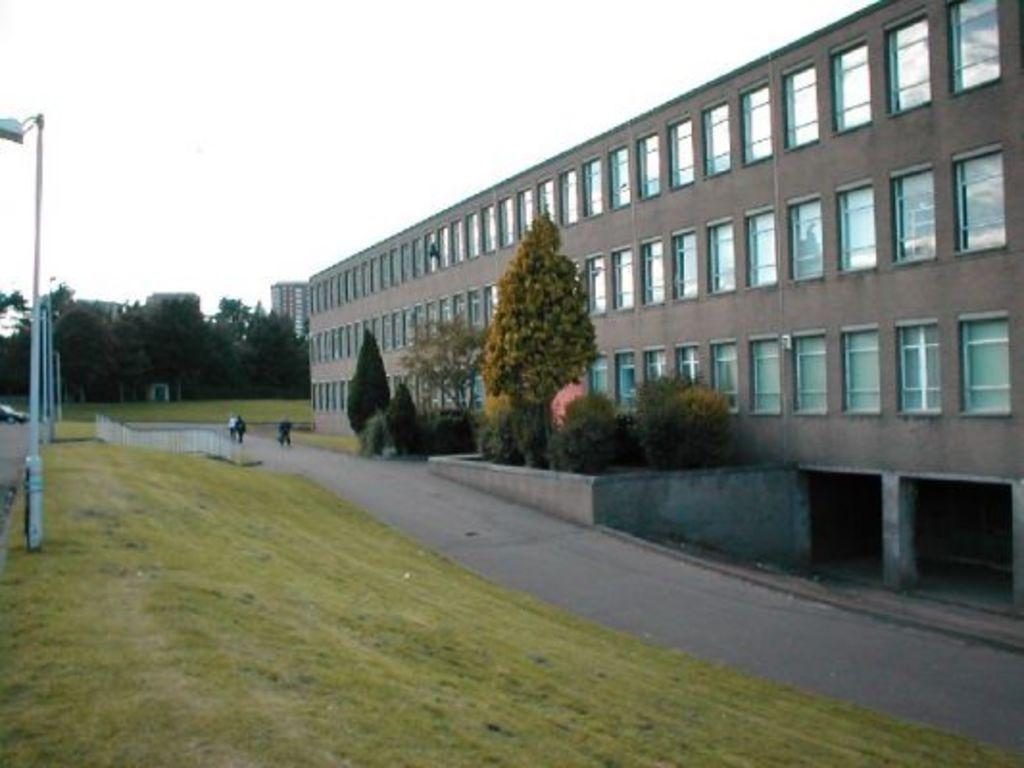What type of structures can be seen in the image? There are buildings in the image. What natural elements are present in the image? There are trees, plants, grass, and the sky visible in the image. What artificial elements can be seen in the image? There is a street lamp and a fence in the image. Are there any living beings visible in the image? Yes, there are people visible in the image. What arithmetic problem is being solved by the trees in the image? There is no arithmetic problem being solved by the trees in the image; they are natural elements in the scene. Can you tell me which knee belongs to the person on the left in the image? There is no specific person mentioned in the image, and even if there were, we cannot determine the position of their knees from the provided facts. 